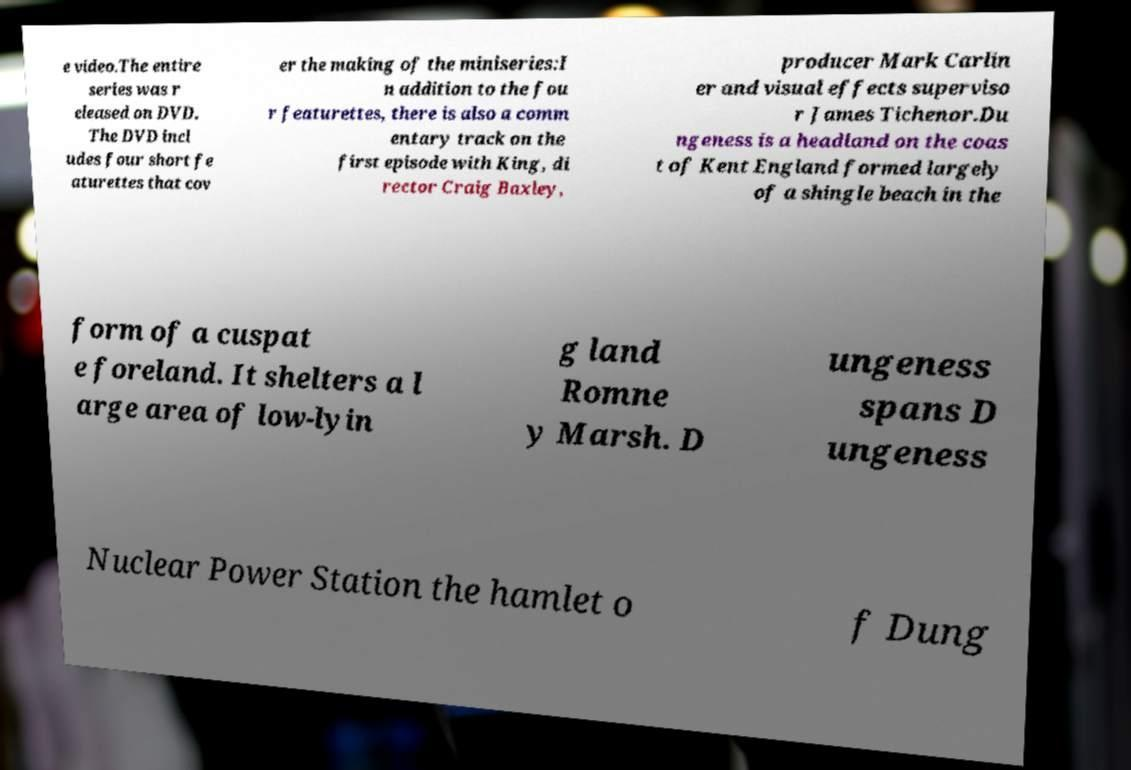There's text embedded in this image that I need extracted. Can you transcribe it verbatim? e video.The entire series was r eleased on DVD. The DVD incl udes four short fe aturettes that cov er the making of the miniseries:I n addition to the fou r featurettes, there is also a comm entary track on the first episode with King, di rector Craig Baxley, producer Mark Carlin er and visual effects superviso r James Tichenor.Du ngeness is a headland on the coas t of Kent England formed largely of a shingle beach in the form of a cuspat e foreland. It shelters a l arge area of low-lyin g land Romne y Marsh. D ungeness spans D ungeness Nuclear Power Station the hamlet o f Dung 